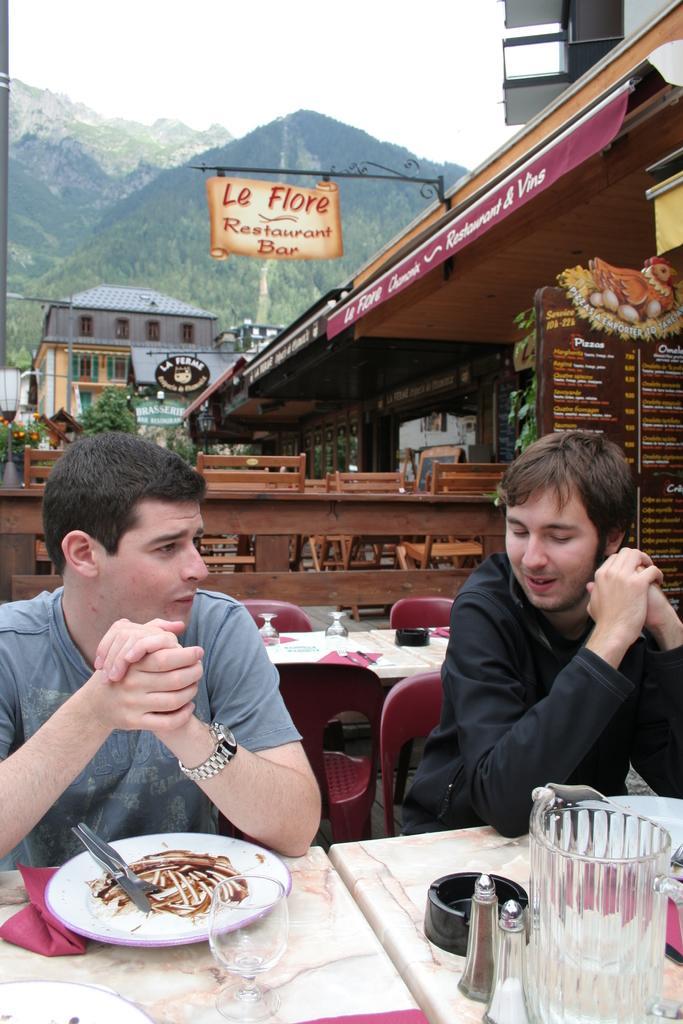How would you summarize this image in a sentence or two? In this image there is a restaurant on the right. In the middle there is a table on that there is a plate, jug and glass, in front of that table there are two man sitting on the chair. In the background there is a building, hill, poster and sky. 